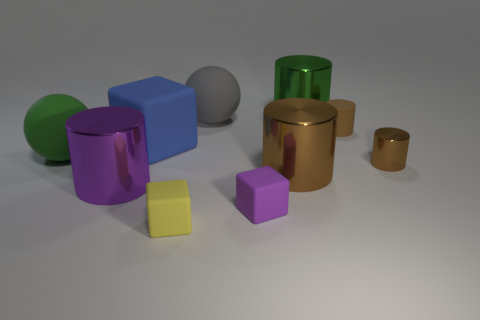Are the brown thing on the left side of the brown matte cylinder and the blue object made of the same material?
Provide a succinct answer. No. Are there more large things to the right of the large purple object than large matte blocks to the right of the large gray sphere?
Offer a terse response. Yes. How many objects are either purple things on the left side of the gray thing or small gray shiny balls?
Your answer should be compact. 1. There is a blue thing that is made of the same material as the yellow object; what is its shape?
Your answer should be compact. Cube. There is a rubber object that is to the right of the tiny yellow matte object and in front of the blue object; what color is it?
Your answer should be compact. Purple. What number of cylinders are gray rubber objects or small brown matte things?
Provide a short and direct response. 1. How many other metallic objects are the same size as the yellow thing?
Your response must be concise. 1. There is a yellow matte thing that is in front of the purple metallic cylinder; how many gray rubber things are left of it?
Offer a very short reply. 0. How big is the cylinder that is in front of the large gray matte thing and behind the tiny metallic cylinder?
Offer a very short reply. Small. Is the number of tiny yellow rubber cylinders greater than the number of matte spheres?
Your response must be concise. No. 